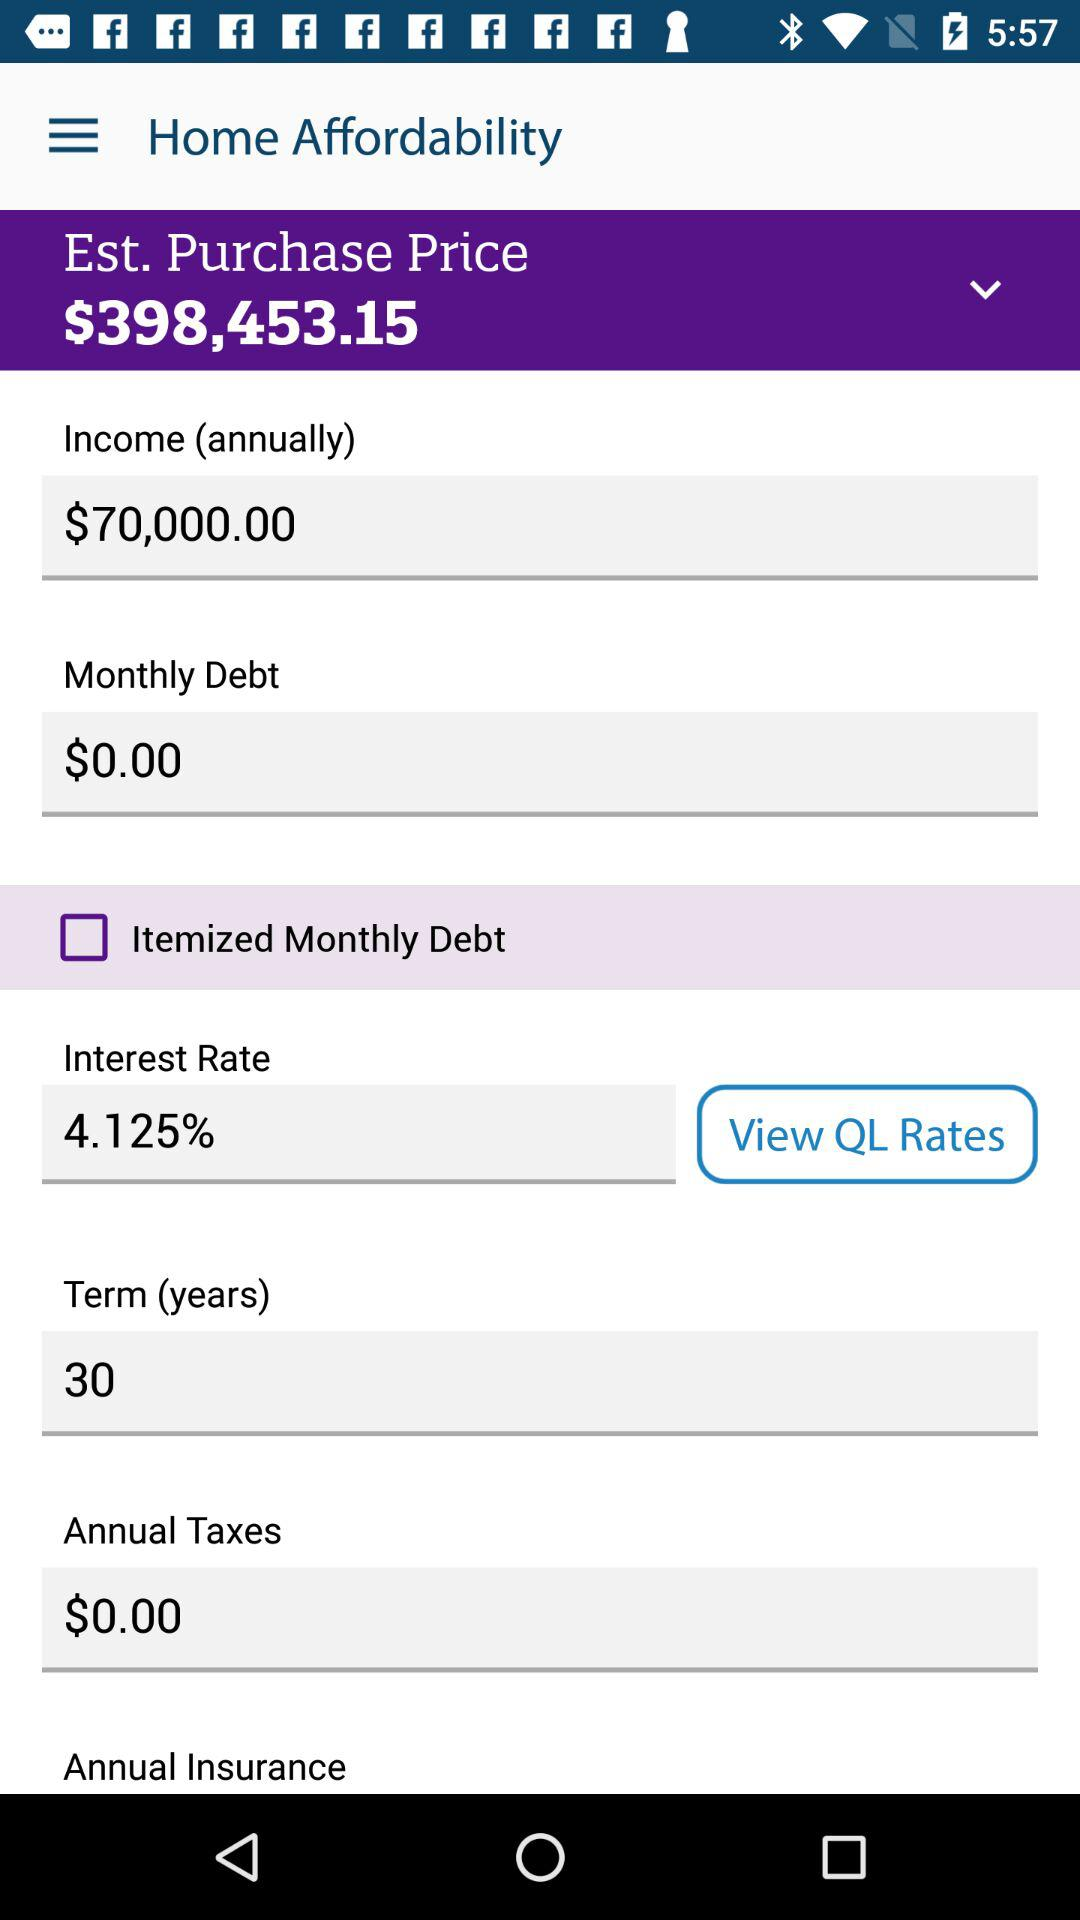What is the estimated purchase price? The estimate purchase price is $398,453.15. 